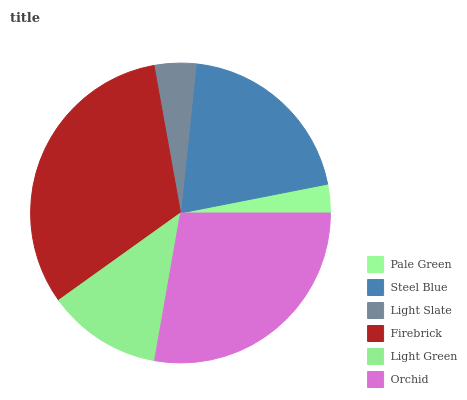Is Pale Green the minimum?
Answer yes or no. Yes. Is Firebrick the maximum?
Answer yes or no. Yes. Is Steel Blue the minimum?
Answer yes or no. No. Is Steel Blue the maximum?
Answer yes or no. No. Is Steel Blue greater than Pale Green?
Answer yes or no. Yes. Is Pale Green less than Steel Blue?
Answer yes or no. Yes. Is Pale Green greater than Steel Blue?
Answer yes or no. No. Is Steel Blue less than Pale Green?
Answer yes or no. No. Is Steel Blue the high median?
Answer yes or no. Yes. Is Light Green the low median?
Answer yes or no. Yes. Is Orchid the high median?
Answer yes or no. No. Is Light Slate the low median?
Answer yes or no. No. 